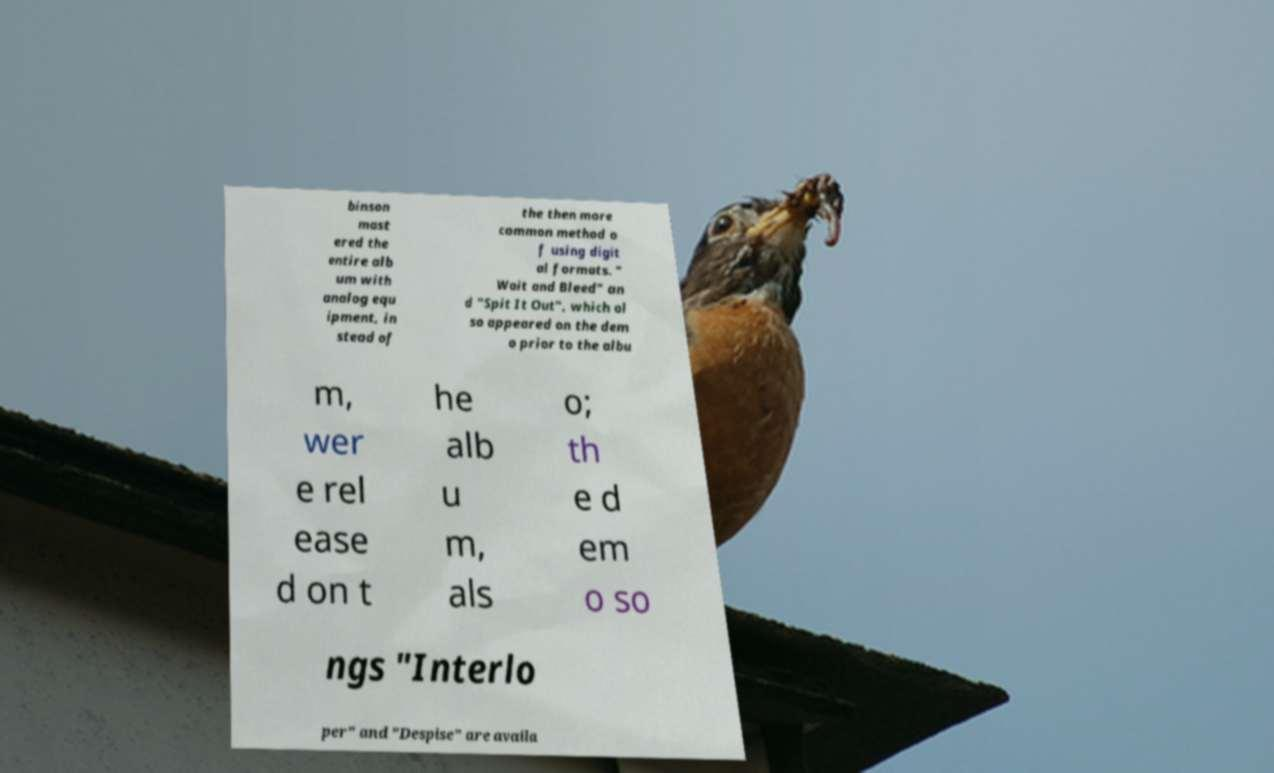I need the written content from this picture converted into text. Can you do that? binson mast ered the entire alb um with analog equ ipment, in stead of the then more common method o f using digit al formats. " Wait and Bleed" an d "Spit It Out", which al so appeared on the dem o prior to the albu m, wer e rel ease d on t he alb u m, als o; th e d em o so ngs "Interlo per" and "Despise" are availa 